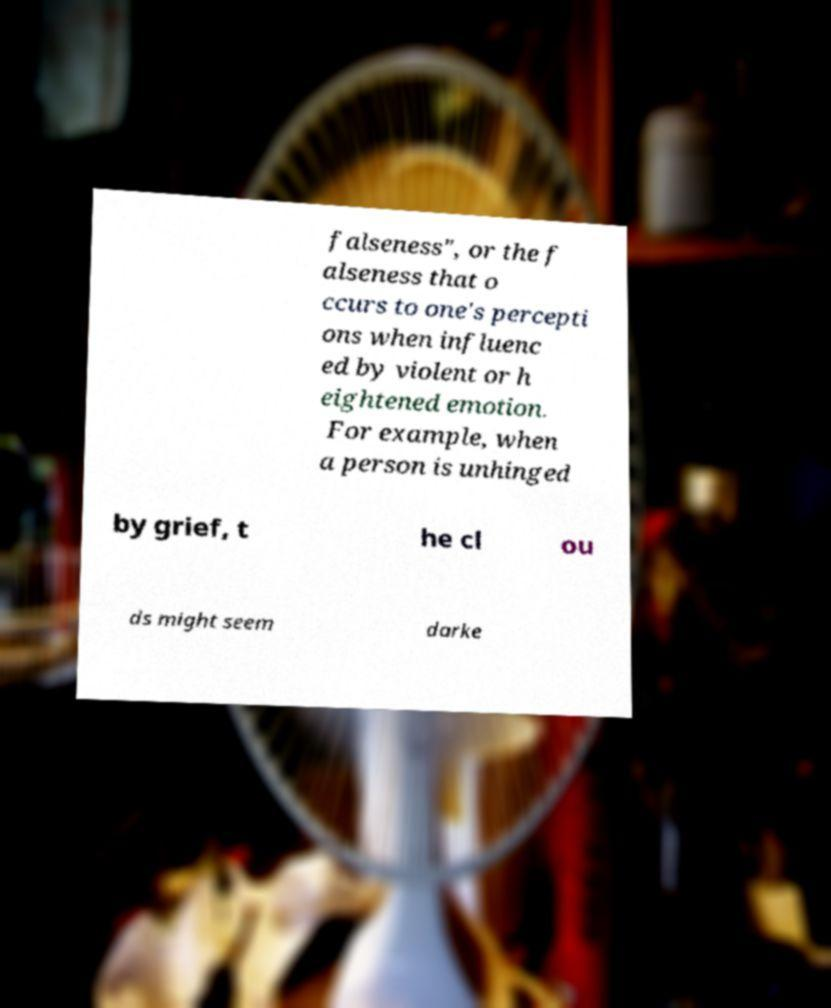There's text embedded in this image that I need extracted. Can you transcribe it verbatim? falseness", or the f alseness that o ccurs to one's percepti ons when influenc ed by violent or h eightened emotion. For example, when a person is unhinged by grief, t he cl ou ds might seem darke 